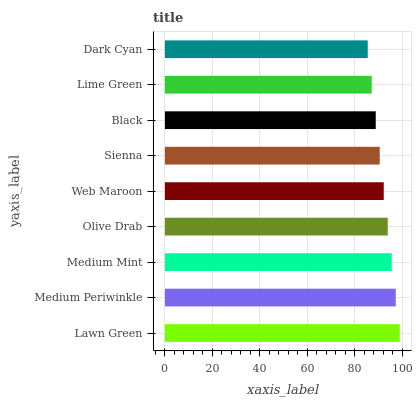Is Dark Cyan the minimum?
Answer yes or no. Yes. Is Lawn Green the maximum?
Answer yes or no. Yes. Is Medium Periwinkle the minimum?
Answer yes or no. No. Is Medium Periwinkle the maximum?
Answer yes or no. No. Is Lawn Green greater than Medium Periwinkle?
Answer yes or no. Yes. Is Medium Periwinkle less than Lawn Green?
Answer yes or no. Yes. Is Medium Periwinkle greater than Lawn Green?
Answer yes or no. No. Is Lawn Green less than Medium Periwinkle?
Answer yes or no. No. Is Web Maroon the high median?
Answer yes or no. Yes. Is Web Maroon the low median?
Answer yes or no. Yes. Is Lime Green the high median?
Answer yes or no. No. Is Sienna the low median?
Answer yes or no. No. 